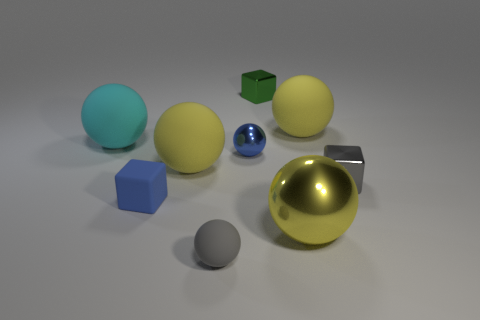What is the size of the matte thing that is behind the large cyan object?
Offer a terse response. Large. What color is the large matte sphere that is behind the ball left of the yellow rubber thing that is left of the tiny green thing?
Your answer should be compact. Yellow. The tiny metallic cube that is in front of the big yellow matte ball left of the gray matte ball is what color?
Offer a very short reply. Gray. Is the number of tiny shiny balls that are behind the small green metal block greater than the number of big cyan objects that are in front of the gray rubber sphere?
Your answer should be compact. No. Are the tiny object that is behind the cyan sphere and the small gray thing behind the small blue matte cube made of the same material?
Give a very brief answer. Yes. Are there any blue matte blocks on the left side of the large metal ball?
Your answer should be very brief. Yes. How many purple things are either matte things or shiny cubes?
Your response must be concise. 0. Is the green thing made of the same material as the gray thing that is right of the small green cube?
Your answer should be very brief. Yes. What is the size of the other metallic object that is the same shape as the tiny blue metal thing?
Give a very brief answer. Large. What is the material of the blue ball?
Your answer should be very brief. Metal. 